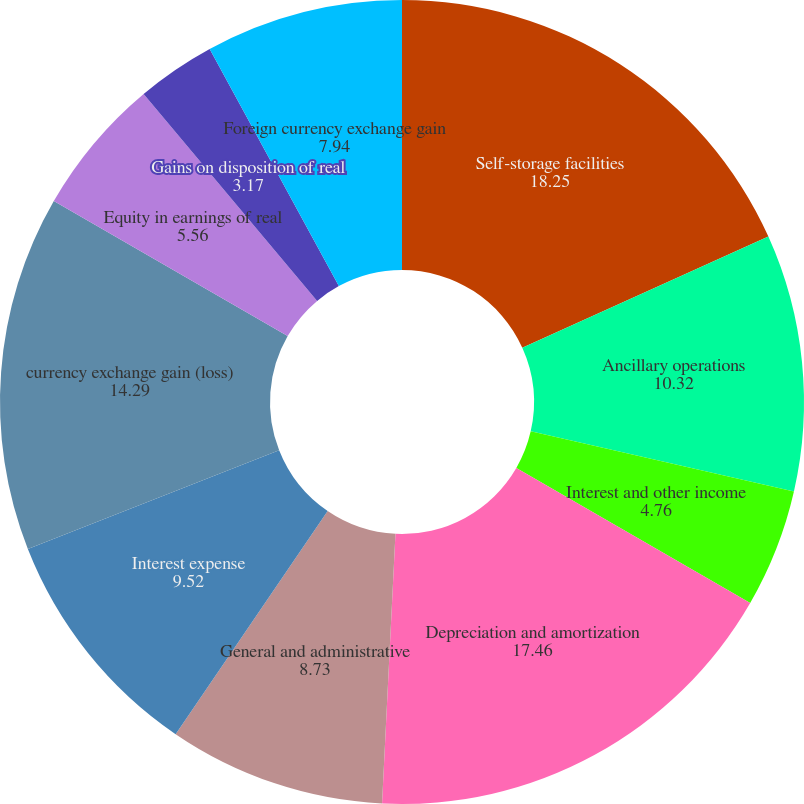<chart> <loc_0><loc_0><loc_500><loc_500><pie_chart><fcel>Self-storage facilities<fcel>Ancillary operations<fcel>Interest and other income<fcel>Depreciation and amortization<fcel>General and administrative<fcel>Interest expense<fcel>currency exchange gain (loss)<fcel>Equity in earnings of real<fcel>Gains on disposition of real<fcel>Foreign currency exchange gain<nl><fcel>18.25%<fcel>10.32%<fcel>4.76%<fcel>17.46%<fcel>8.73%<fcel>9.52%<fcel>14.29%<fcel>5.56%<fcel>3.17%<fcel>7.94%<nl></chart> 